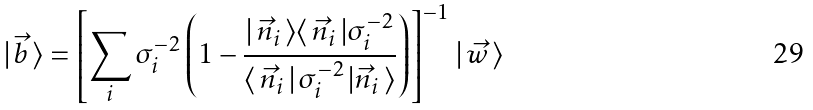<formula> <loc_0><loc_0><loc_500><loc_500>| \, \vec { b } \, \rangle = \left [ \sum _ { i } { \boldmath \sigma } _ { i } ^ { - 2 } \left ( { \boldmath 1 } - \frac { | \, \vec { n } _ { i } \, \rangle \langle \, \vec { n } _ { i } \, | { \boldmath \sigma } _ { i } ^ { - 2 } } { \langle \, \vec { n } _ { i } \, | \, { \boldmath \sigma } _ { i } ^ { - 2 } \, | \vec { n } _ { i } \, \rangle } \right ) \right ] ^ { - 1 } \, | \, \vec { w } \, \rangle</formula> 